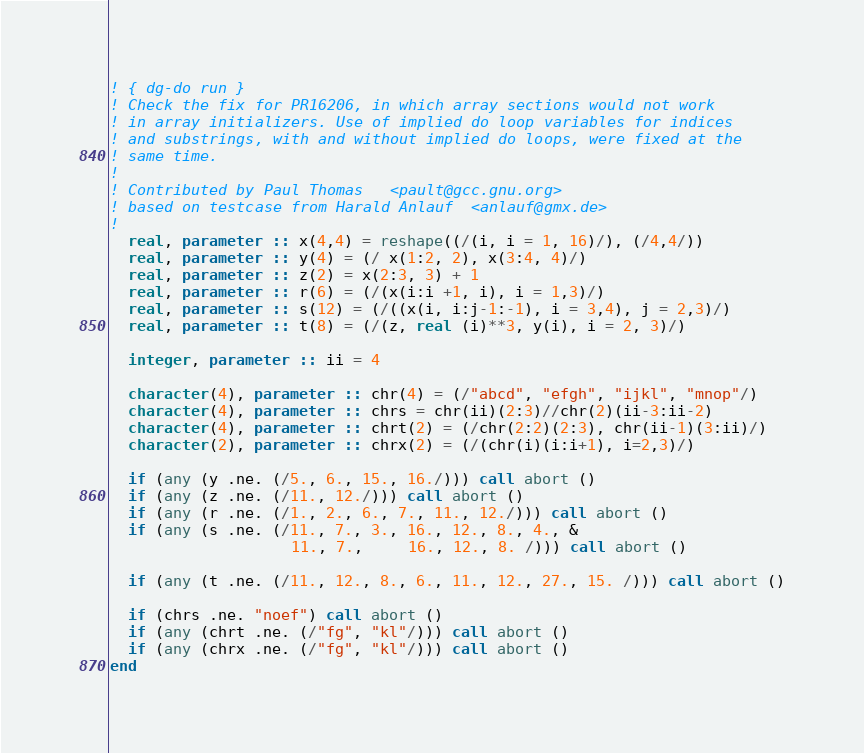<code> <loc_0><loc_0><loc_500><loc_500><_FORTRAN_>! { dg-do run }
! Check the fix for PR16206, in which array sections would not work
! in array initializers. Use of implied do loop variables for indices
! and substrings, with and without implied do loops, were fixed at the
! same time.
!
! Contributed by Paul Thomas   <pault@gcc.gnu.org>
! based on testcase from Harald Anlauf  <anlauf@gmx.de>  
!
  real, parameter :: x(4,4) = reshape((/(i, i = 1, 16)/), (/4,4/))
  real, parameter :: y(4) = (/ x(1:2, 2), x(3:4, 4)/)
  real, parameter :: z(2) = x(2:3, 3) + 1
  real, parameter :: r(6) = (/(x(i:i +1, i), i = 1,3)/)
  real, parameter :: s(12) = (/((x(i, i:j-1:-1), i = 3,4), j = 2,3)/)
  real, parameter :: t(8) = (/(z, real (i)**3, y(i), i = 2, 3)/)

  integer, parameter :: ii = 4

  character(4), parameter :: chr(4) = (/"abcd", "efgh", "ijkl", "mnop"/)
  character(4), parameter :: chrs = chr(ii)(2:3)//chr(2)(ii-3:ii-2) 
  character(4), parameter :: chrt(2) = (/chr(2:2)(2:3), chr(ii-1)(3:ii)/)
  character(2), parameter :: chrx(2) = (/(chr(i)(i:i+1), i=2,3)/)

  if (any (y .ne. (/5., 6., 15., 16./))) call abort ()
  if (any (z .ne. (/11., 12./))) call abort ()
  if (any (r .ne. (/1., 2., 6., 7., 11., 12./))) call abort ()
  if (any (s .ne. (/11., 7., 3., 16., 12., 8., 4., &
                    11., 7.,     16., 12., 8. /))) call abort ()

  if (any (t .ne. (/11., 12., 8., 6., 11., 12., 27., 15. /))) call abort ()

  if (chrs .ne. "noef") call abort ()
  if (any (chrt .ne. (/"fg", "kl"/))) call abort ()
  if (any (chrx .ne. (/"fg", "kl"/))) call abort ()
end
</code> 